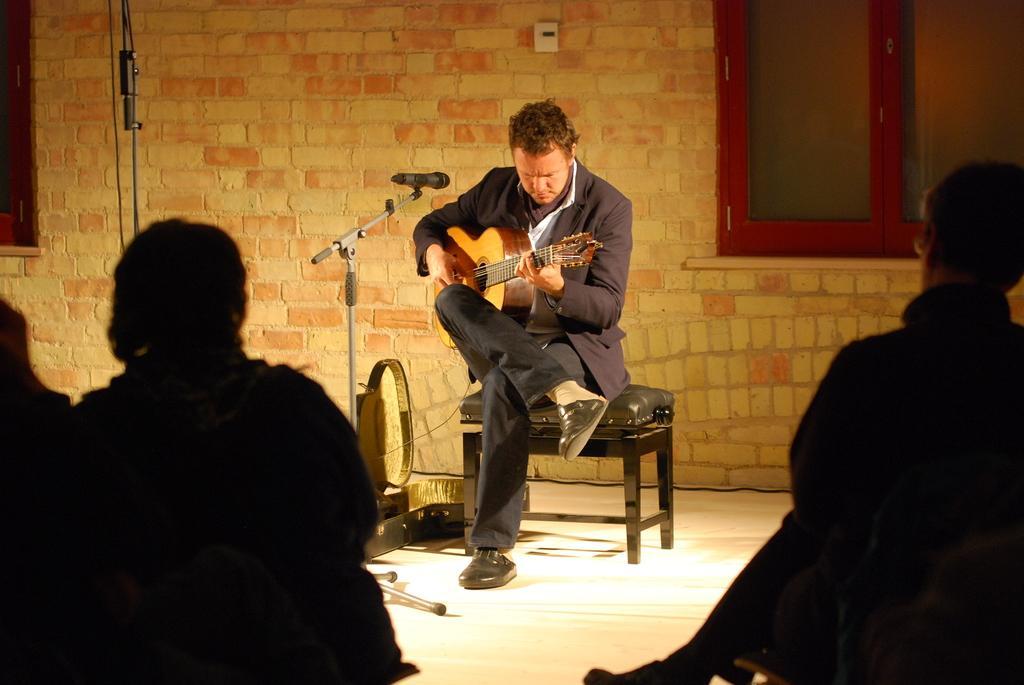In one or two sentences, can you explain what this image depicts? The picture is taken in a room where one person is sitting in the centre on the chair wearing a suit and holding a guitar in front of the microphone, behind him there is a wall and window and in front of him there is a crowd. 